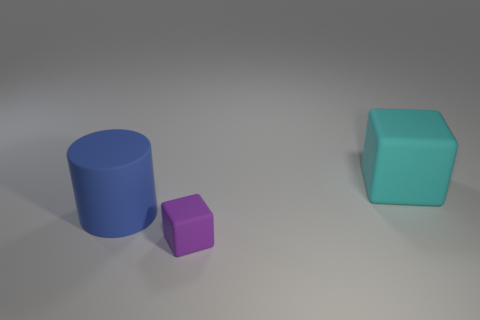Are there fewer small matte blocks behind the matte cylinder than purple rubber blocks that are on the left side of the cyan rubber object?
Keep it short and to the point. Yes. There is a large matte thing that is on the left side of the rubber cube that is behind the blue thing; what is its shape?
Offer a terse response. Cylinder. Are there any blue rubber cylinders?
Ensure brevity in your answer.  Yes. There is a thing that is to the right of the tiny purple object; what color is it?
Offer a terse response. Cyan. There is a blue cylinder; are there any tiny things to the left of it?
Offer a terse response. No. Is the number of small objects greater than the number of small red metallic spheres?
Provide a succinct answer. Yes. There is a block that is on the right side of the block that is left of the rubber cube behind the tiny rubber block; what is its color?
Your answer should be very brief. Cyan. The cylinder that is the same material as the big block is what color?
Your answer should be compact. Blue. Is there anything else that has the same size as the cyan object?
Offer a very short reply. Yes. What number of things are either rubber objects that are behind the rubber cylinder or large matte objects to the right of the purple object?
Your response must be concise. 1. 